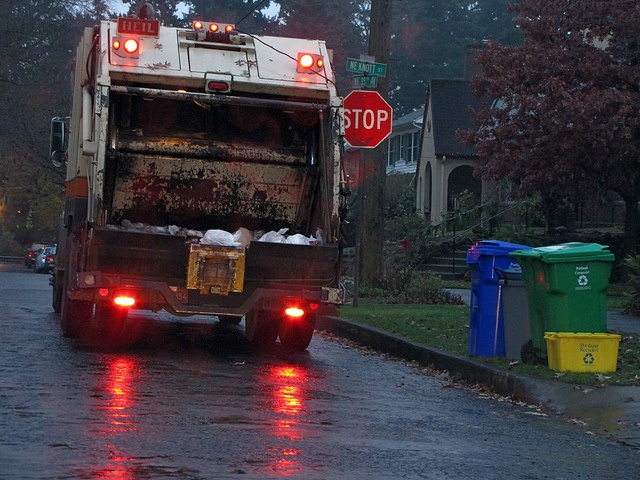Describe the objects in this image and their specific colors. I can see truck in black, maroon, gray, and darkgray tones, stop sign in black, brown, maroon, and darkgray tones, car in black, gray, and blue tones, and car in black, gray, and purple tones in this image. 